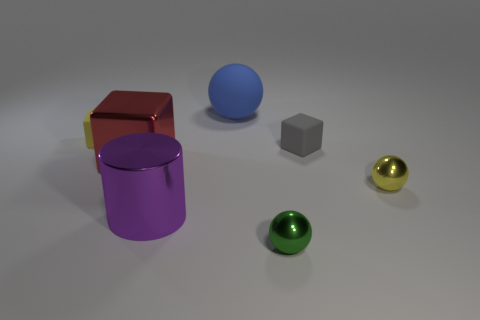Subtract all blue rubber balls. How many balls are left? 2 Add 2 blue objects. How many objects exist? 9 Subtract all green spheres. How many spheres are left? 2 Subtract all cubes. How many objects are left? 4 Subtract all gray cylinders. Subtract all cyan spheres. How many cylinders are left? 1 Subtract all yellow cylinders. How many blue spheres are left? 1 Subtract all large yellow cylinders. Subtract all big red metallic blocks. How many objects are left? 6 Add 5 big spheres. How many big spheres are left? 6 Add 6 small gray blocks. How many small gray blocks exist? 7 Subtract 1 green balls. How many objects are left? 6 